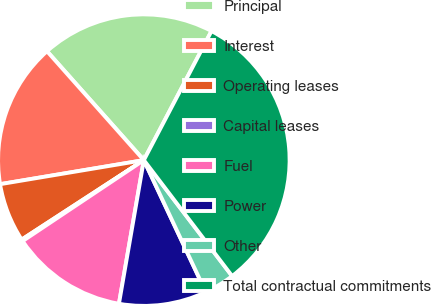Convert chart. <chart><loc_0><loc_0><loc_500><loc_500><pie_chart><fcel>Principal<fcel>Interest<fcel>Operating leases<fcel>Capital leases<fcel>Fuel<fcel>Power<fcel>Other<fcel>Total contractual commitments<nl><fcel>19.25%<fcel>16.07%<fcel>6.54%<fcel>0.19%<fcel>12.9%<fcel>9.72%<fcel>3.37%<fcel>31.96%<nl></chart> 